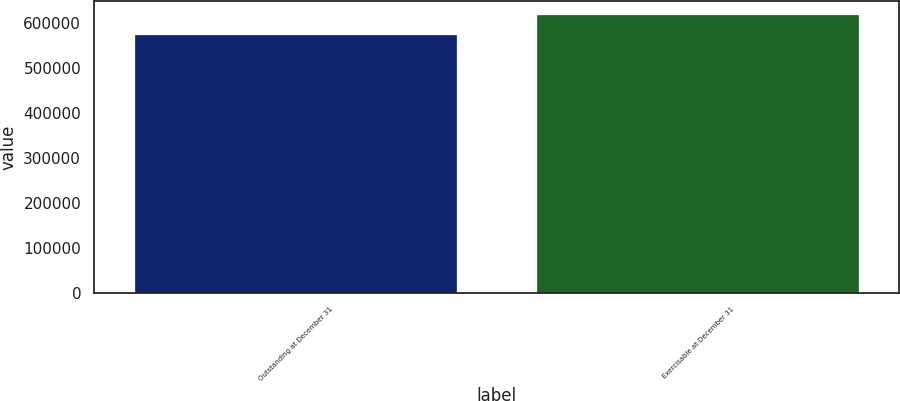Convert chart to OTSL. <chart><loc_0><loc_0><loc_500><loc_500><bar_chart><fcel>Outstanding at December 31<fcel>Exercisable at December 31<nl><fcel>572976<fcel>617832<nl></chart> 